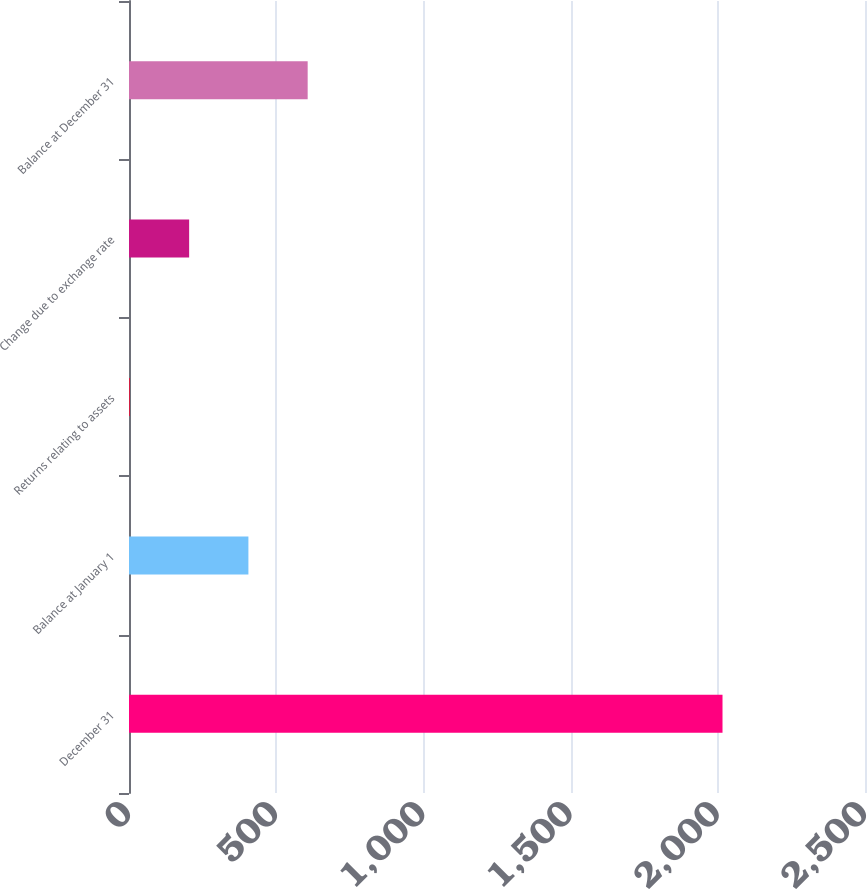<chart> <loc_0><loc_0><loc_500><loc_500><bar_chart><fcel>December 31<fcel>Balance at January 1<fcel>Returns relating to assets<fcel>Change due to exchange rate<fcel>Balance at December 31<nl><fcel>2016<fcel>405.6<fcel>3<fcel>204.3<fcel>606.9<nl></chart> 